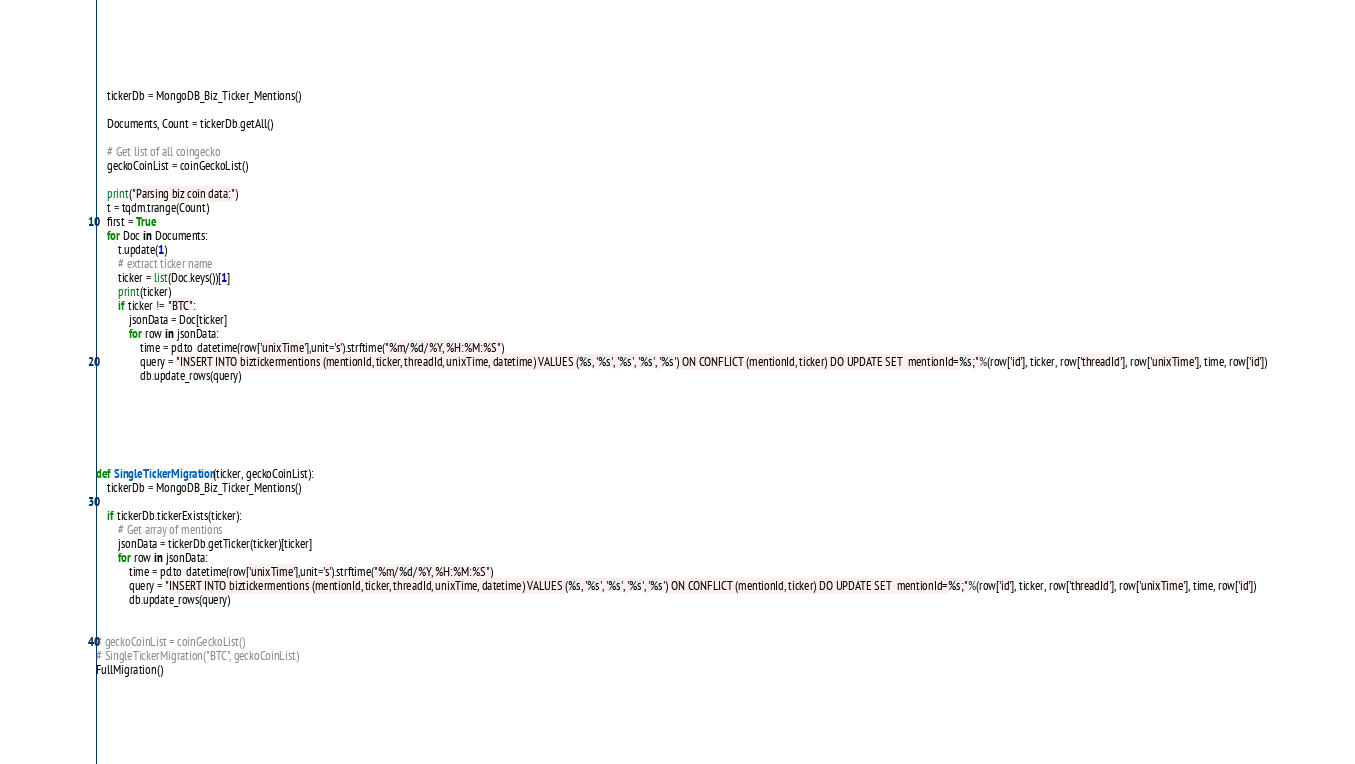Convert code to text. <code><loc_0><loc_0><loc_500><loc_500><_Python_>    tickerDb = MongoDB_Biz_Ticker_Mentions()

    Documents, Count = tickerDb.getAll()

    # Get list of all coingecko
    geckoCoinList = coinGeckoList()

    print("Parsing biz coin data:")
    t = tqdm.trange(Count)
    first = True
    for Doc in Documents:
        t.update(1)
        # extract ticker name
        ticker = list(Doc.keys())[1]
        print(ticker)
        if ticker != "BTC":
            jsonData = Doc[ticker]
            for row in jsonData:
                time = pd.to_datetime(row['unixTime'],unit='s').strftime("%m/%d/%Y, %H:%M:%S")
                query = "INSERT INTO biztickermentions (mentionId, ticker, threadId, unixTime, datetime) VALUES (%s, '%s', '%s', '%s', '%s') ON CONFLICT (mentionId, ticker) DO UPDATE SET  mentionId=%s;"%(row['id'], ticker, row['threadId'], row['unixTime'], time, row['id'])
                db.update_rows(query)

   




def SingleTickerMigration(ticker, geckoCoinList):
    tickerDb = MongoDB_Biz_Ticker_Mentions()

    if tickerDb.tickerExists(ticker):
        # Get array of mentions
        jsonData = tickerDb.getTicker(ticker)[ticker]
        for row in jsonData:
            time = pd.to_datetime(row['unixTime'],unit='s').strftime("%m/%d/%Y, %H:%M:%S")
            query = "INSERT INTO biztickermentions (mentionId, ticker, threadId, unixTime, datetime) VALUES (%s, '%s', '%s', '%s', '%s') ON CONFLICT (mentionId, ticker) DO UPDATE SET  mentionId=%s;"%(row['id'], ticker, row['threadId'], row['unixTime'], time, row['id'])
            db.update_rows(query)


# geckoCoinList = coinGeckoList()
# SingleTickerMigration("BTC", geckoCoinList)
FullMigration()</code> 